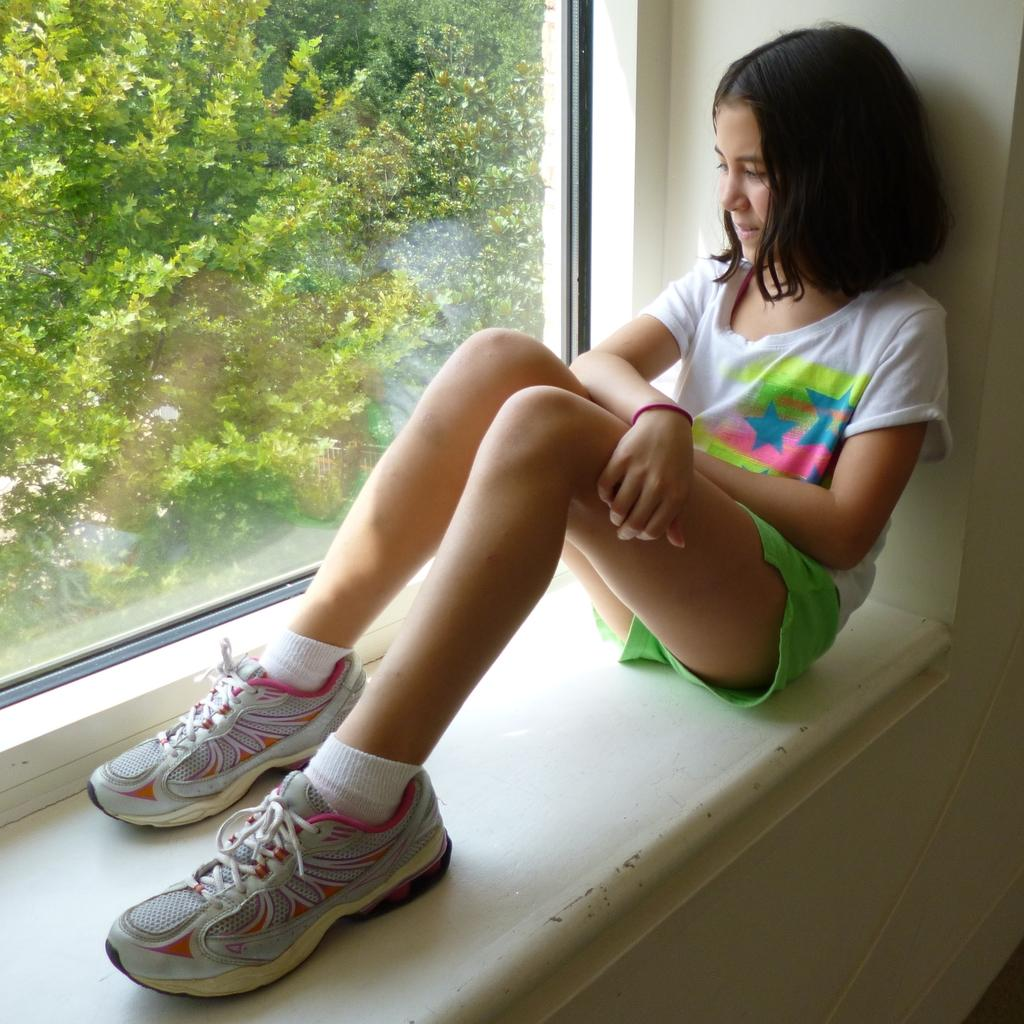What is the person in the image doing? There is a person sitting in the image. What is the person wearing? The person is wearing a white and green color dress. What can be seen in the background of the image? There is a glass window and trees in green color in the background of the image. What is the temperature of the hot air balloon in the image? There is no hot air balloon present in the image. 